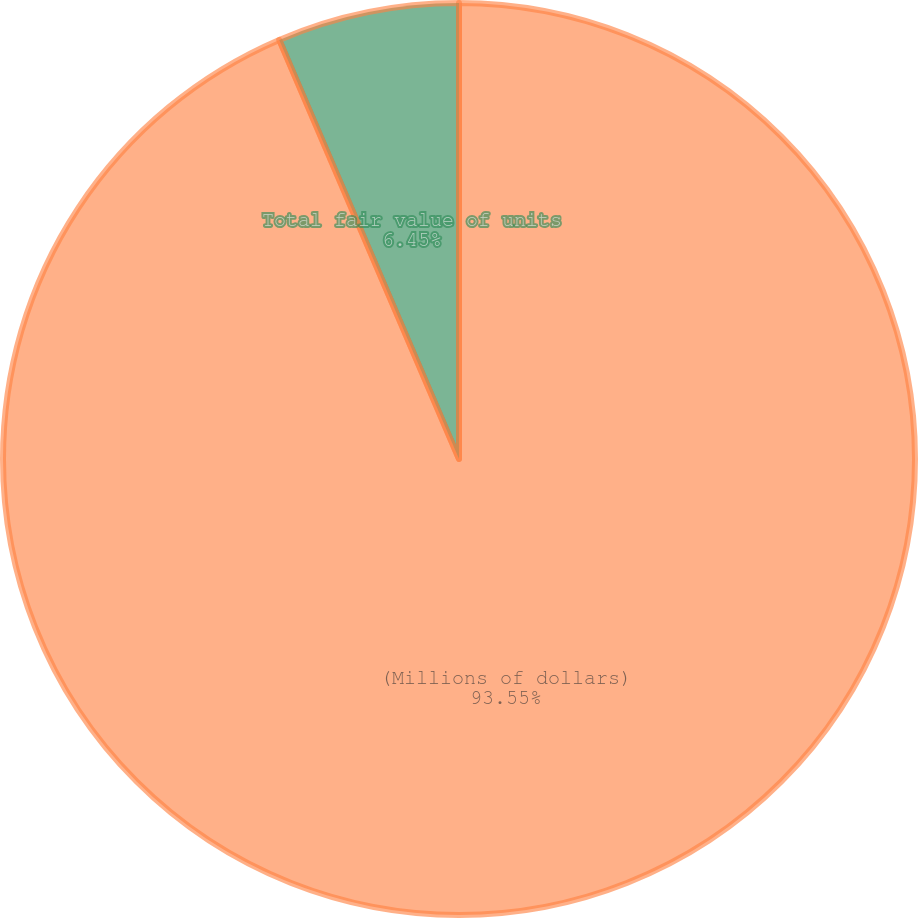Convert chart to OTSL. <chart><loc_0><loc_0><loc_500><loc_500><pie_chart><fcel>(Millions of dollars)<fcel>Total fair value of units<nl><fcel>93.55%<fcel>6.45%<nl></chart> 